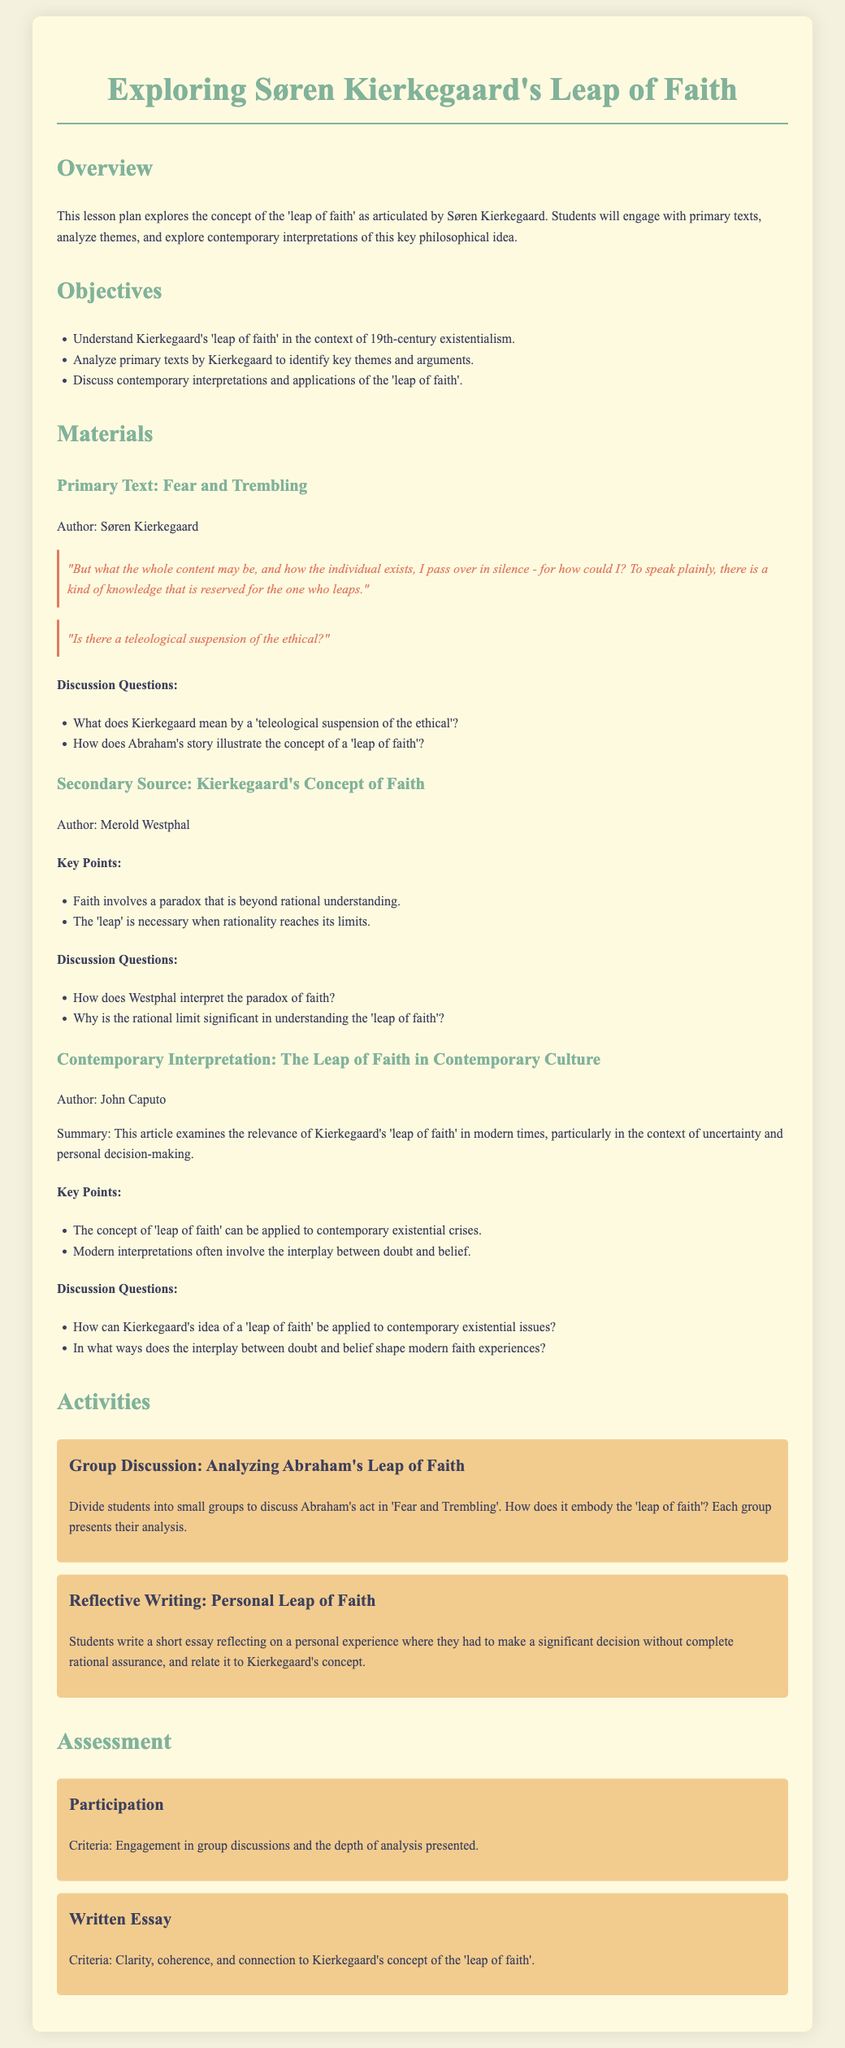What is the title of the lesson plan? The title of the lesson plan is explicitly mentioned at the top of the document.
Answer: Exploring Søren Kierkegaard's Leap of Faith Who is the author of the primary text discussed? The author of the primary text 'Fear and Trembling' is stated in the materials section.
Answer: Søren Kierkegaard What is one key point from Merold Westphal's secondary source? The document lists key points from Westphal's interpretation under the secondary source section.
Answer: Faith involves a paradox that is beyond rational understanding What are the two types of activities included in the lesson plan? The types of activities are listed within the activities section of the document.
Answer: Group Discussion and Reflective Writing What is the primary objective related to understanding Kierkegaard's leap of faith? One of the objectives specifically addresses understanding Kierkegaard's idea in a certain philosophical context.
Answer: 19th-century existentialism What is one of the assessment criteria for student participation? The assessment section outlines specific criteria for evaluating participation in discussions.
Answer: Engagement in group discussions How does the document describe contemporary interpretations of the leap of faith? The summary in the contemporary interpretation section comments on the modern relevance of the concept.
Answer: Relevance in modern times How many discussion questions are listed under 'Fear and Trembling'? The document provides a specific number of discussion questions associated with the primary text.
Answer: Two 